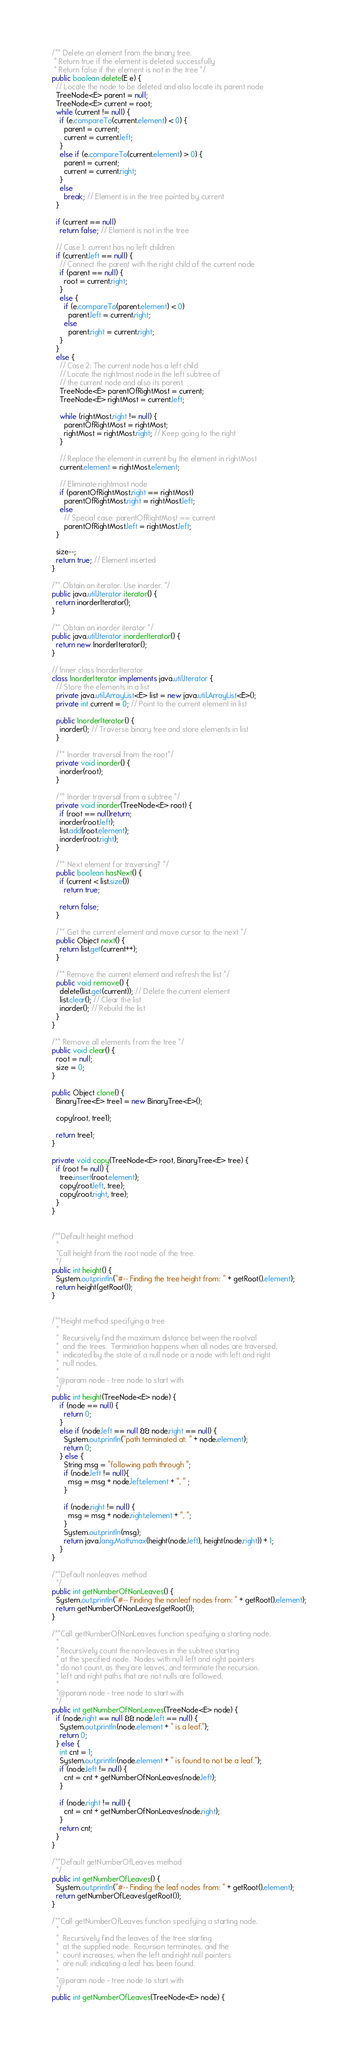<code> <loc_0><loc_0><loc_500><loc_500><_Java_>  /** Delete an element from the binary tree.
   * Return true if the element is deleted successfully
   * Return false if the element is not in the tree */
  public boolean delete(E e) {
    // Locate the node to be deleted and also locate its parent node
    TreeNode<E> parent = null;
    TreeNode<E> current = root;
    while (current != null) {
      if (e.compareTo(current.element) < 0) {
        parent = current;
        current = current.left;
      }
      else if (e.compareTo(current.element) > 0) {
        parent = current;
        current = current.right;
      }
      else
        break; // Element is in the tree pointed by current
    }

    if (current == null)
      return false; // Element is not in the tree

    // Case 1: current has no left children
    if (current.left == null) {
      // Connect the parent with the right child of the current node
      if (parent == null) {
        root = current.right;
      }
      else {
        if (e.compareTo(parent.element) < 0)
          parent.left = current.right;
        else
          parent.right = current.right;
      }
    }
    else {
      // Case 2: The current node has a left child
      // Locate the rightmost node in the left subtree of
      // the current node and also its parent
      TreeNode<E> parentOfRightMost = current;
      TreeNode<E> rightMost = current.left;

      while (rightMost.right != null) {
        parentOfRightMost = rightMost;
        rightMost = rightMost.right; // Keep going to the right
      }

      // Replace the element in current by the element in rightMost
      current.element = rightMost.element;

      // Eliminate rightmost node
      if (parentOfRightMost.right == rightMost)
        parentOfRightMost.right = rightMost.left;
      else
        // Special case: parentOfRightMost == current
        parentOfRightMost.left = rightMost.left;
    }

    size--;
    return true; // Element inserted
  }

  /** Obtain an iterator. Use inorder. */
  public java.util.Iterator iterator() {
    return inorderIterator();
  }

  /** Obtain an inorder iterator */
  public java.util.Iterator inorderIterator() {
    return new InorderIterator();
  }

  // Inner class InorderIterator
  class InorderIterator implements java.util.Iterator {
    // Store the elements in a list
    private java.util.ArrayList<E> list = new java.util.ArrayList<E>();
    private int current = 0; // Point to the current element in list

    public InorderIterator() {
      inorder(); // Traverse binary tree and store elements in list
    }

    /** Inorder traversal from the root*/
    private void inorder() {
      inorder(root);
    }

    /** Inorder traversal from a subtree */
    private void inorder(TreeNode<E> root) {
      if (root == null)return;
      inorder(root.left);
      list.add(root.element);
      inorder(root.right);
    }

    /** Next element for traversing? */
    public boolean hasNext() {
      if (current < list.size())
        return true;

      return false;
    }

    /** Get the current element and move cursor to the next */
    public Object next() {
      return list.get(current++);
    }

    /** Remove the current element and refresh the list */
    public void remove() {
      delete(list.get(current)); // Delete the current element
      list.clear(); // Clear the list
      inorder(); // Rebuild the list
    }
  }

  /** Remove all elements from the tree */
  public void clear() {
    root = null;
    size = 0;
  }

  public Object clone() {
    BinaryTree<E> tree1 = new BinaryTree<E>();

    copy(root, tree1);

    return tree1;
  }

  private void copy(TreeNode<E> root, BinaryTree<E> tree) {
    if (root != null) {
      tree.insert(root.element);
      copy(root.left, tree);
      copy(root.right, tree);
    }
  }


  /**Default height method
    *
    *Call height from the root node of the tree.
    */
  public int height() {
    System.out.println("#-- Finding the tree height from: " + getRoot().element);
    return height(getRoot());
  }


  /**Height method specifying a tree
    *
    *  Recursively find the maximum distance between the rootval
    *  and the trees.  Termination happens when all nodes are traversed,
    *  indicated by the state of a null node or a node with left and right
    *  null nodes.
    *
    *@param node - tree node to start with
    */
  public int height(TreeNode<E> node) {
      if (node == null) {
        return 0;
      }
      else if (node.left == null && node.right == null) {
        System.out.println("path terminated at: " + node.element);
        return 0;
      } else {
        String msg = "following path through ";
        if (node.left != null){
          msg = msg + node.left.element + ", " ;
        }

        if (node.right != null) {
          msg = msg + node.right.element + ", ";
        }
        System.out.println(msg);
        return java.lang.Math.max(height(node.left), height(node.right)) + 1;
      }
  }

  /**Default nonleaves method
    */
  public int getNumberOfNonLeaves() {
    System.out.println("#-- Finding the nonleaf nodes from: " + getRoot().element);
    return getNumberOfNonLeaves(getRoot());
  }

  /**Call getNumberOfNonLeaves function specifying a starting node.
    *
    * Recursively count the non-leaves in the subtree starting
    * at the specified node.  Nodes with null left and right pointers
    * do not count, as they are leaves, and terminate the recursion.
    * left and right paths that are not nulls are followed.
    *
    *@param node - tree node to start with
    */
  public int getNumberOfNonLeaves(TreeNode<E> node) {
    if (node.right == null && node.left == null) {
      System.out.println(node.element + " is a leaf.");
      return 0;
    } else {
      int cnt = 1;
      System.out.println(node.element + " is found to not be a leaf.");
      if (node.left != null) {
        cnt = cnt + getNumberOfNonLeaves(node.left);
      }

      if (node.right != null) {
        cnt = cnt + getNumberOfNonLeaves(node.right);
      }
      return cnt;
    }
  }

  /**Default getNumberOfLeaves method
    */
  public int getNumberOfLeaves() {
    System.out.println("#-- Finding the leaf nodes from: " + getRoot().element);
    return getNumberOfLeaves(getRoot());
  }

  /**Call getNumberOfLeaves function specifying a starting node.
    *
    *  Recursively find the leaves of the tree starting
    *  at the supplied node.  Recursion terminates, and the
    *  count increases, when the left and right null pointers
    *  are null: indicating a leaf has been found.
    *
    *@param node - tree node to start with
    */
  public int getNumberOfLeaves(TreeNode<E> node) {</code> 